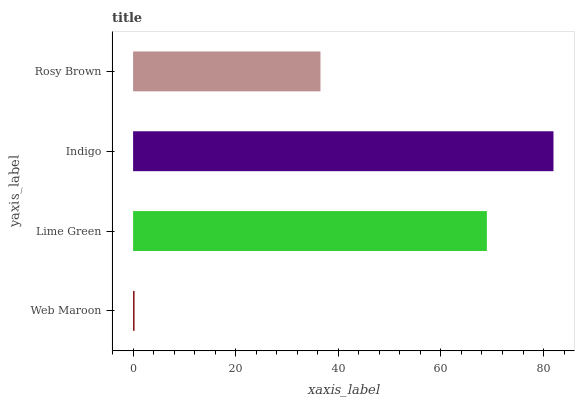Is Web Maroon the minimum?
Answer yes or no. Yes. Is Indigo the maximum?
Answer yes or no. Yes. Is Lime Green the minimum?
Answer yes or no. No. Is Lime Green the maximum?
Answer yes or no. No. Is Lime Green greater than Web Maroon?
Answer yes or no. Yes. Is Web Maroon less than Lime Green?
Answer yes or no. Yes. Is Web Maroon greater than Lime Green?
Answer yes or no. No. Is Lime Green less than Web Maroon?
Answer yes or no. No. Is Lime Green the high median?
Answer yes or no. Yes. Is Rosy Brown the low median?
Answer yes or no. Yes. Is Rosy Brown the high median?
Answer yes or no. No. Is Lime Green the low median?
Answer yes or no. No. 